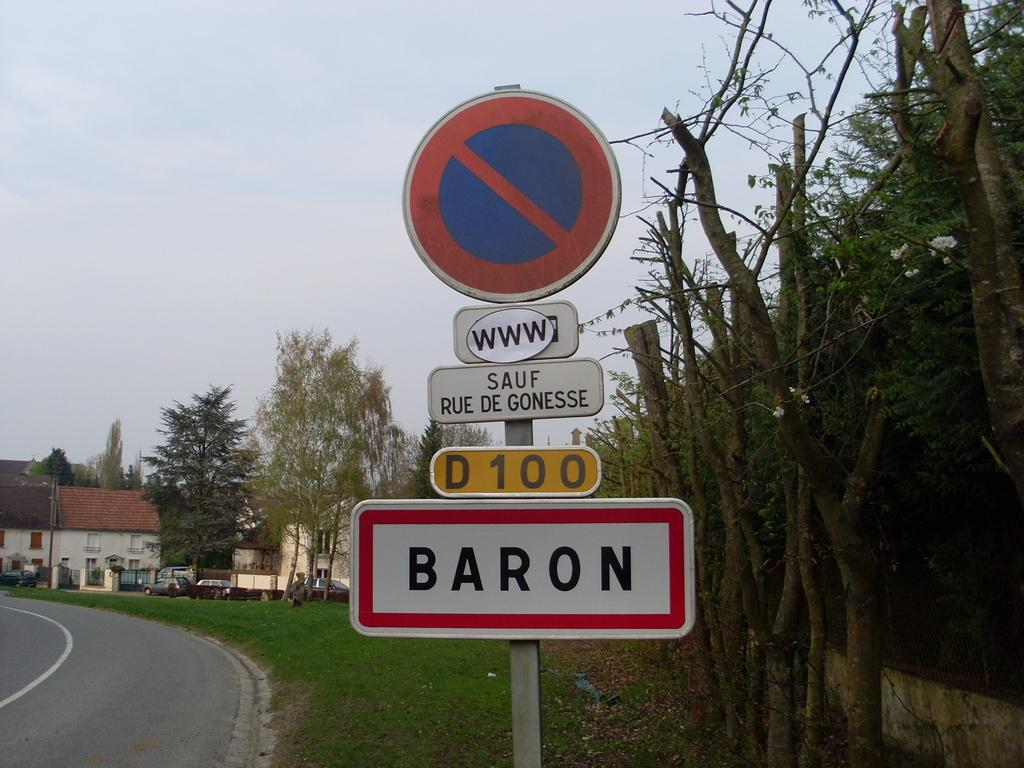<image>
Describe the image concisely. Several road signs together on a pole with the bottom containing the word BARON. 